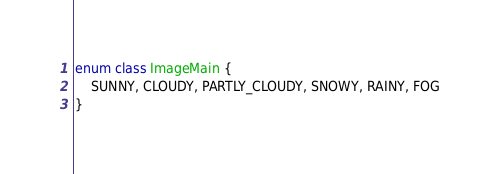<code> <loc_0><loc_0><loc_500><loc_500><_Kotlin_>enum class ImageMain {
    SUNNY, CLOUDY, PARTLY_CLOUDY, SNOWY, RAINY, FOG
}</code> 